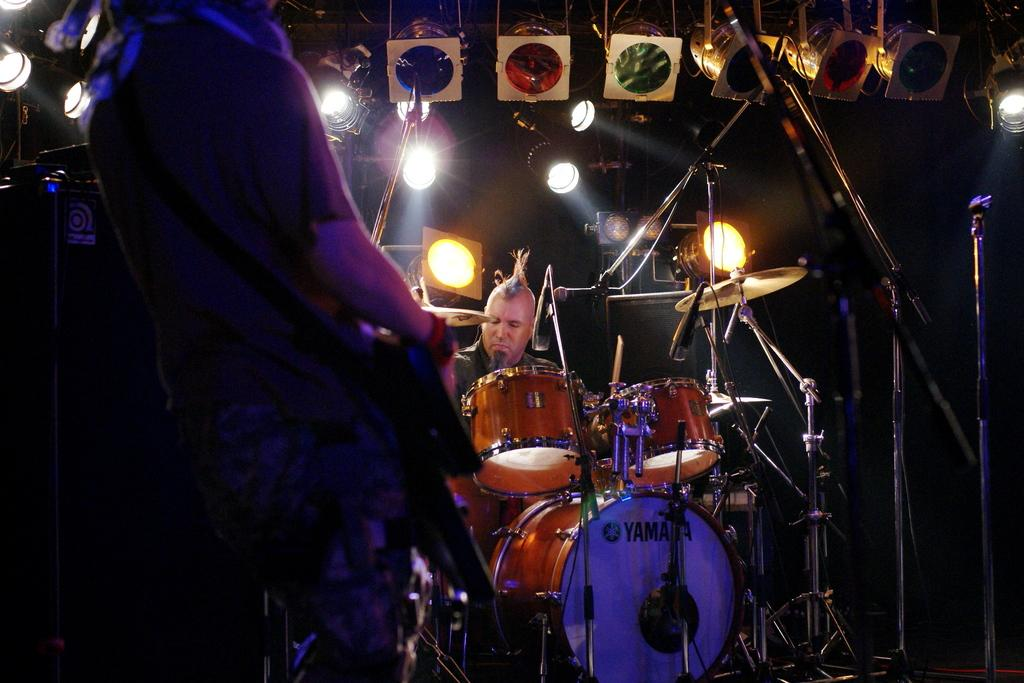What is the main activity being performed by the person in the image? There is a person playing drums in the image. What is the other person in the image doing? There is a person standing and holding an object in the image. What can be seen in the background or surrounding area of the image? There are lights visible in the image. What might be used for amplifying sound in the image? There is a microphone in the image. What type of corn is being used as a prop in the image? There is no corn present in the image. What is the drawer used for in the image? There is no drawer present in the image. 